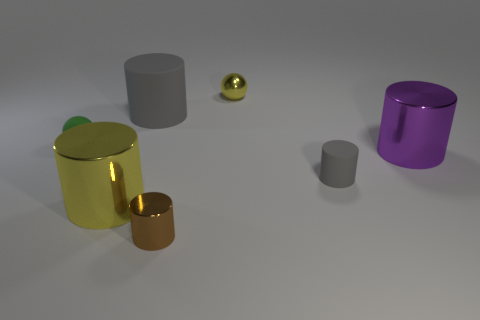Can you describe the largest object in the image? The largest object in the image is a purple cylindrical container with a reflective surface, standing upright on the surface. 